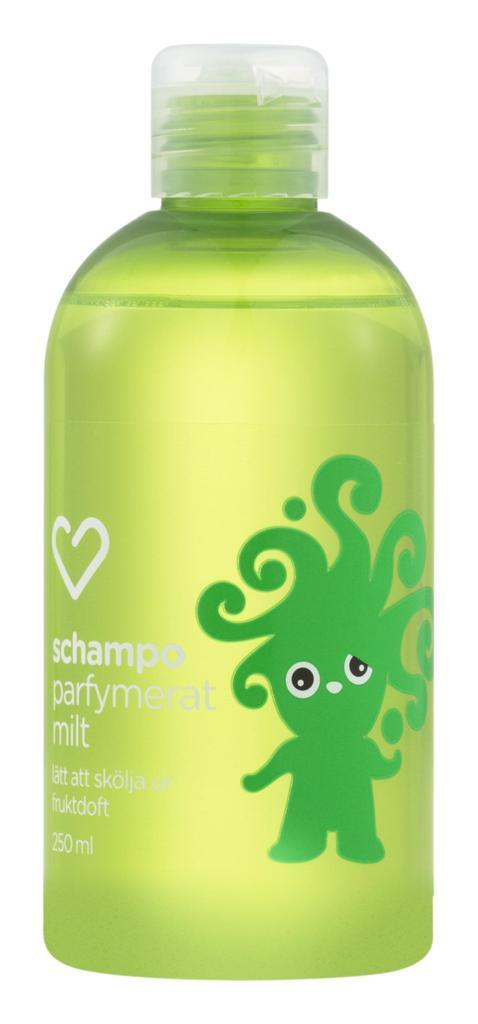Provide a one-sentence caption for the provided image. A bottle of schampo parfymerat milt with a picture of a heart above the saying and a green character on the front of the bottle. 